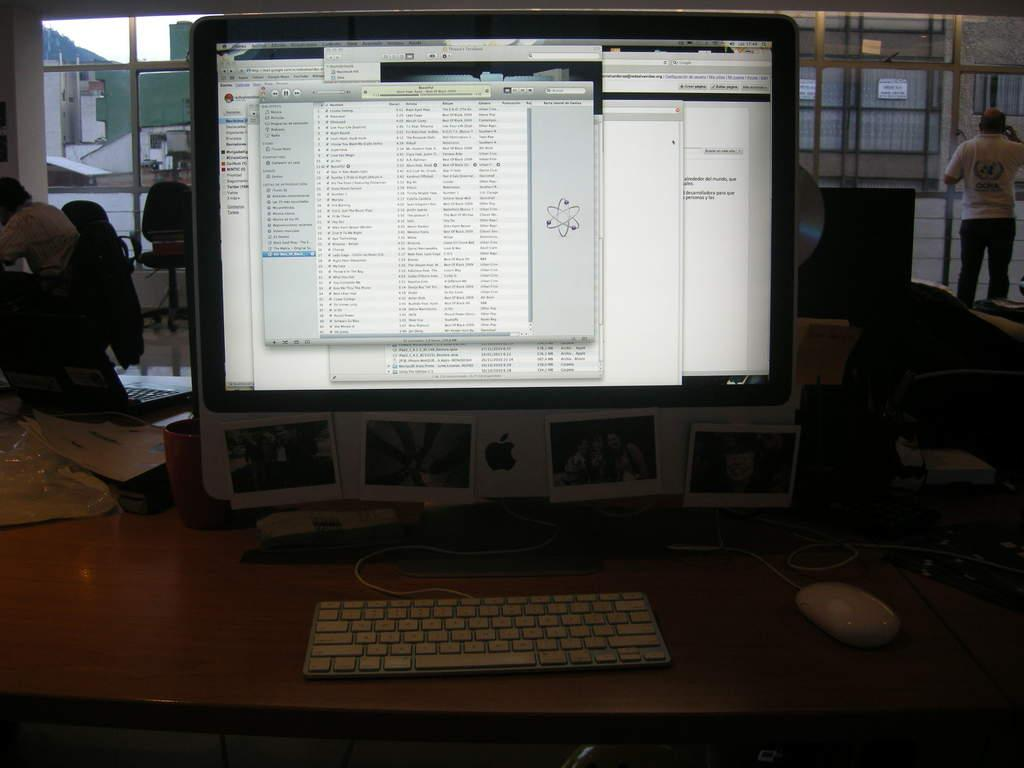Provide a one-sentence caption for the provided image. a mac computer that has the screen open to an itunes tab. 